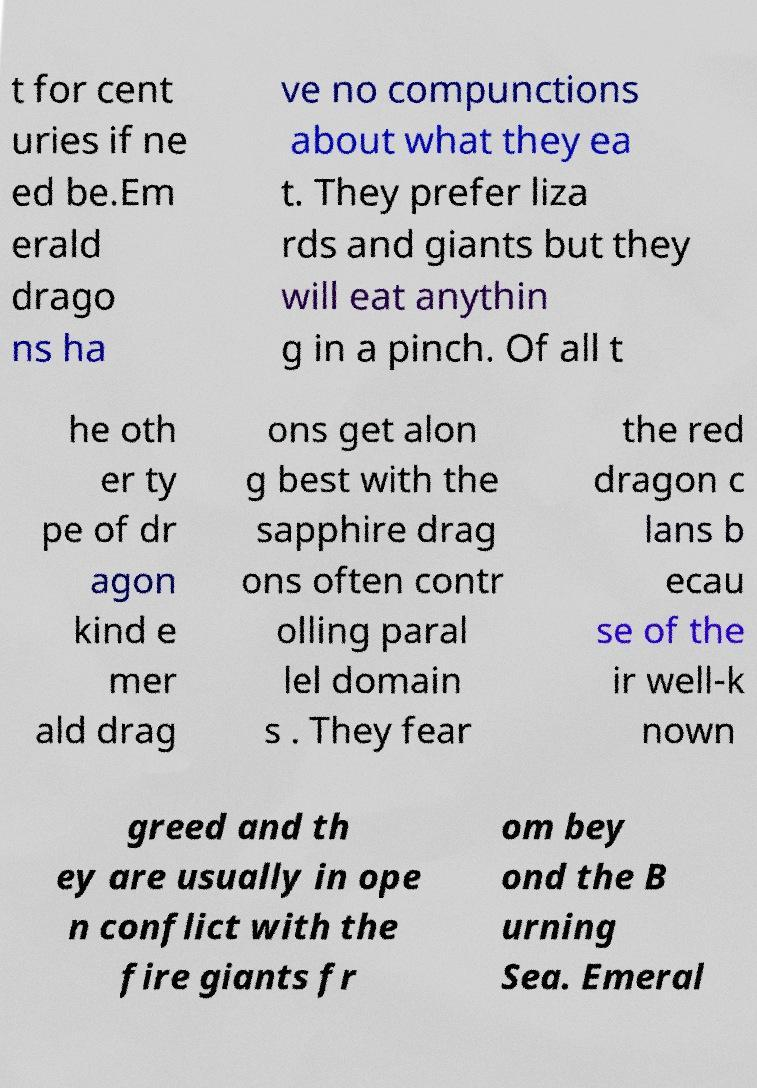Can you accurately transcribe the text from the provided image for me? t for cent uries if ne ed be.Em erald drago ns ha ve no compunctions about what they ea t. They prefer liza rds and giants but they will eat anythin g in a pinch. Of all t he oth er ty pe of dr agon kind e mer ald drag ons get alon g best with the sapphire drag ons often contr olling paral lel domain s . They fear the red dragon c lans b ecau se of the ir well-k nown greed and th ey are usually in ope n conflict with the fire giants fr om bey ond the B urning Sea. Emeral 